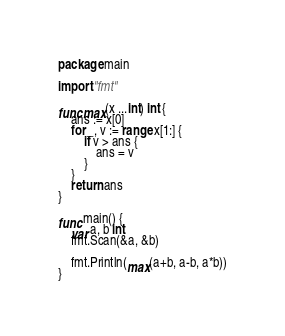Convert code to text. <code><loc_0><loc_0><loc_500><loc_500><_Go_>package main

import "fmt"

func max(x ...int) int {
	ans := x[0]
	for _, v := range x[1:] {
		if v > ans {
			ans = v
		}
	}
	return ans
}

func main() {
	var a, b int
	fmt.Scan(&a, &b)

	fmt.Println(max(a+b, a-b, a*b))
}
</code> 